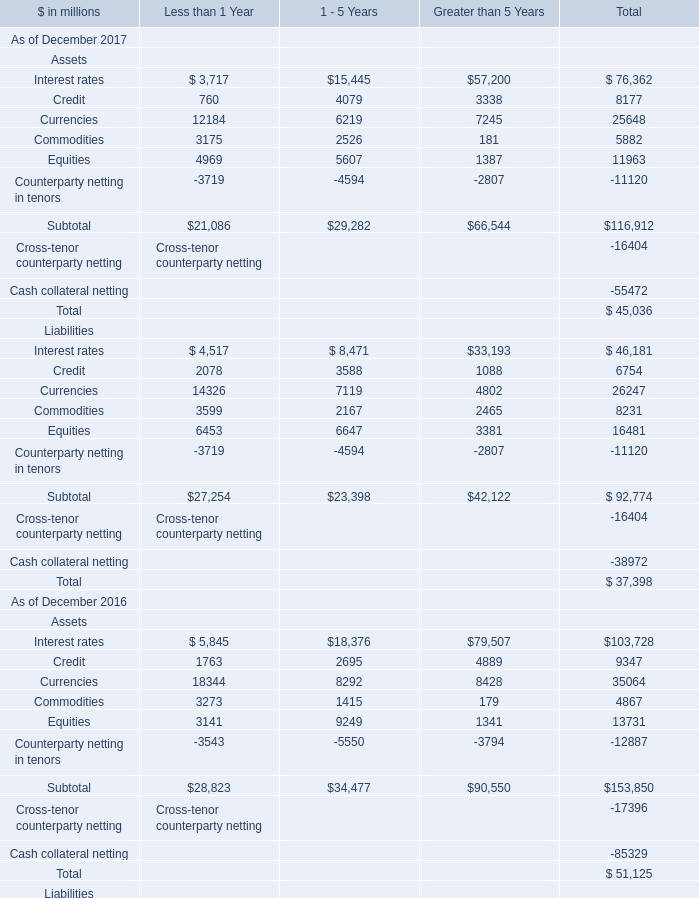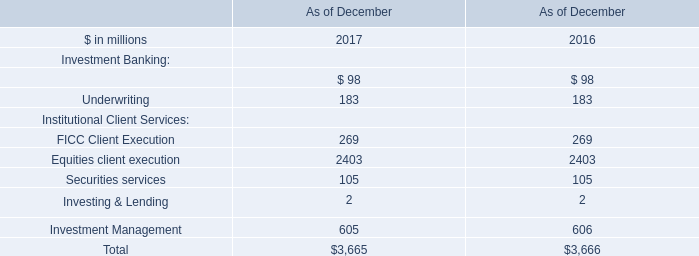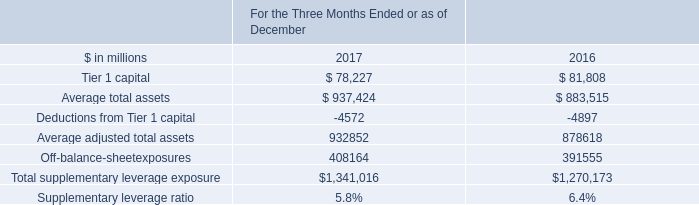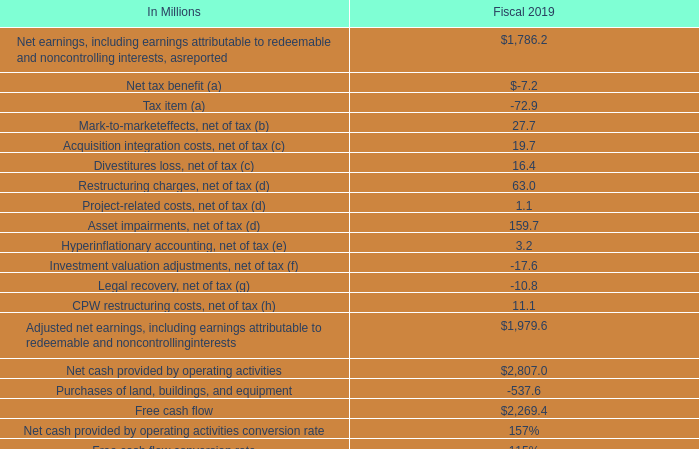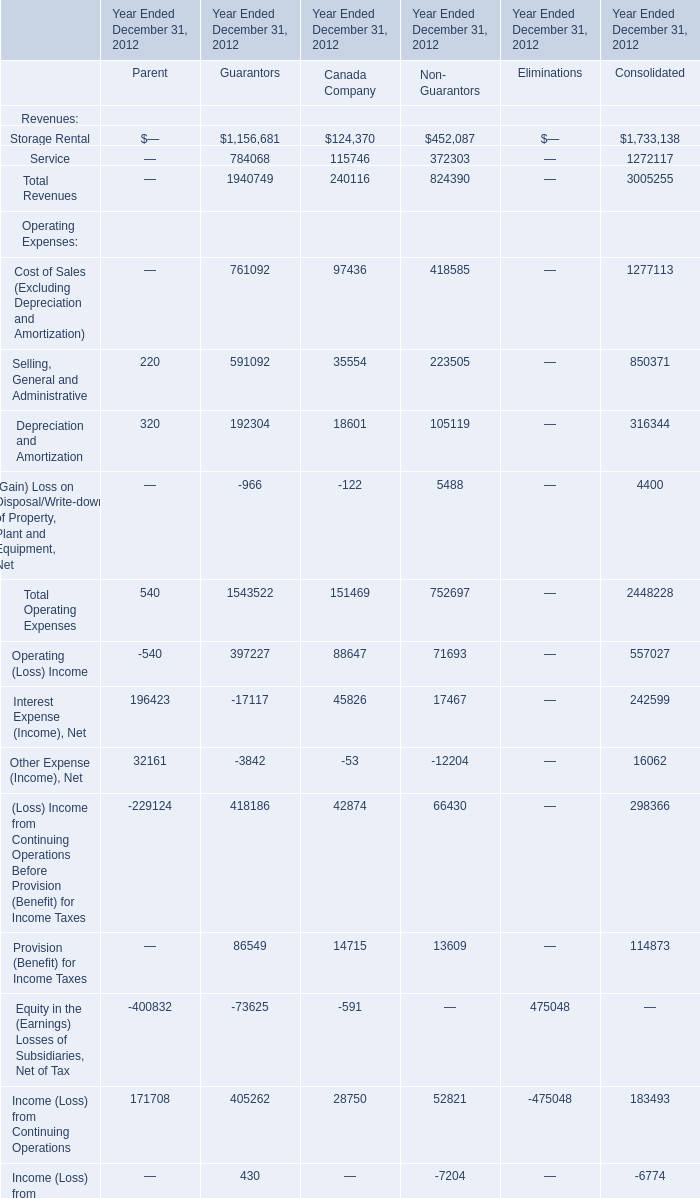for the capital framework , what percent of the minimum supplementary leverage ratio consisted of a buffer? 
Computations: (2 / 5)
Answer: 0.4. 